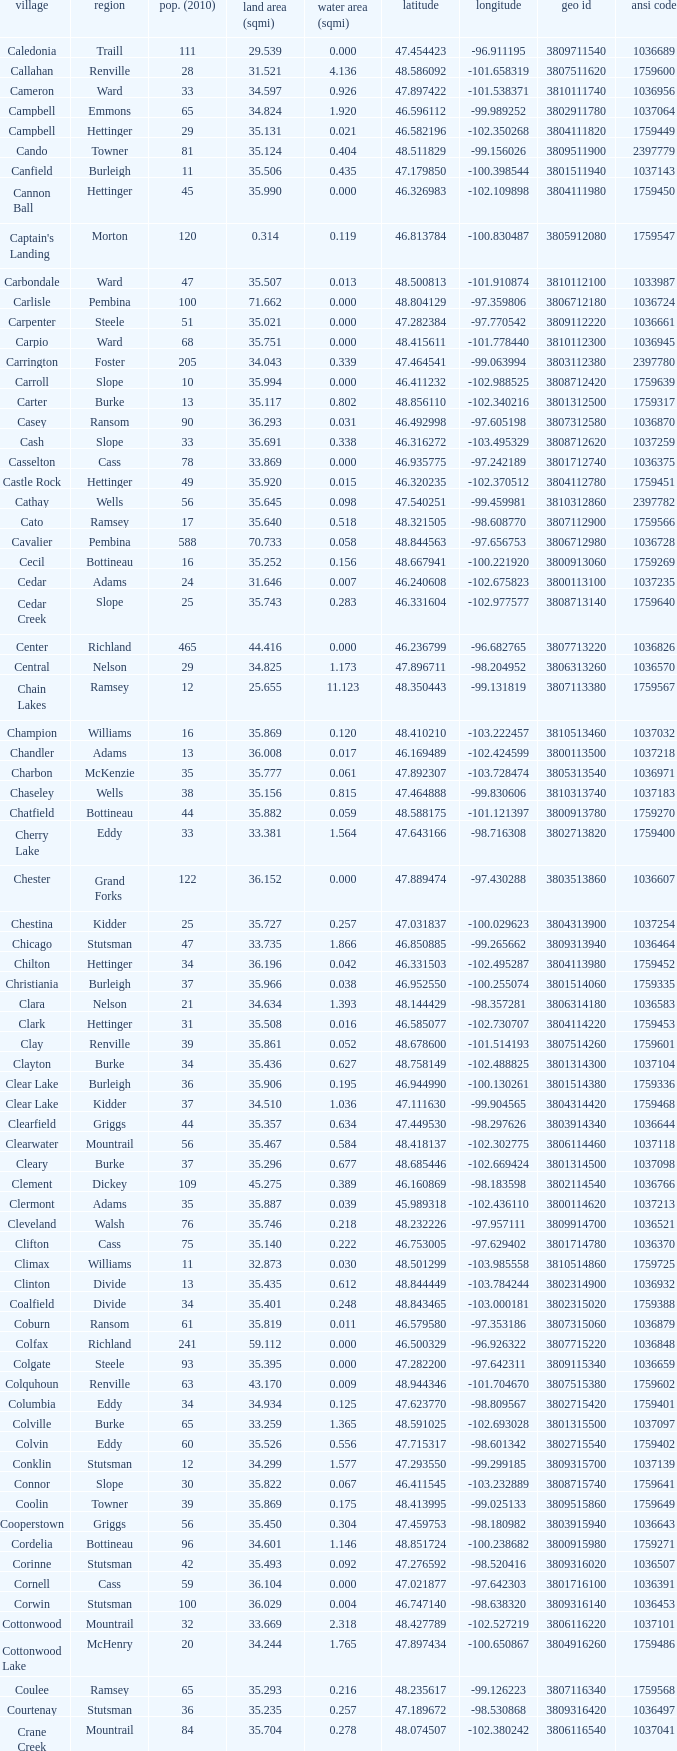What was the land area in sqmi that has a latitude of 48.763937? 35.898. 